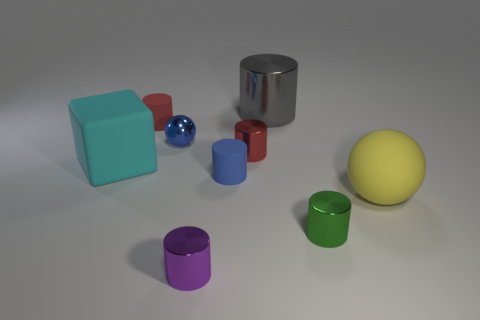Are there any yellow matte things that have the same size as the matte block?
Keep it short and to the point. Yes. There is a small red object right of the blue sphere; what material is it?
Your answer should be very brief. Metal. Is the material of the ball in front of the big cyan matte object the same as the cyan object?
Provide a succinct answer. Yes. What shape is the red matte thing that is the same size as the purple cylinder?
Keep it short and to the point. Cylinder. How many cylinders are the same color as the tiny sphere?
Your response must be concise. 1. Are there fewer tiny balls right of the big yellow ball than cylinders that are right of the red shiny thing?
Your response must be concise. Yes. Are there any metal cylinders in front of the yellow thing?
Offer a terse response. Yes. There is a small cylinder left of the tiny shiny thing in front of the tiny green metal thing; are there any small red objects in front of it?
Keep it short and to the point. Yes. Do the tiny matte object that is on the right side of the purple object and the gray metallic thing have the same shape?
Your response must be concise. Yes. There is a large sphere that is the same material as the blue cylinder; what is its color?
Your answer should be very brief. Yellow. 